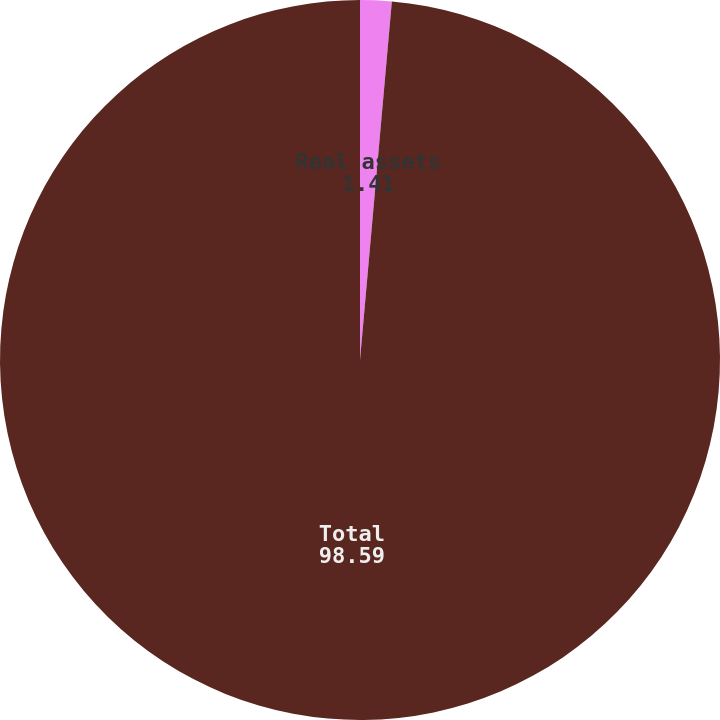Convert chart. <chart><loc_0><loc_0><loc_500><loc_500><pie_chart><fcel>Real assets<fcel>Total<nl><fcel>1.41%<fcel>98.59%<nl></chart> 